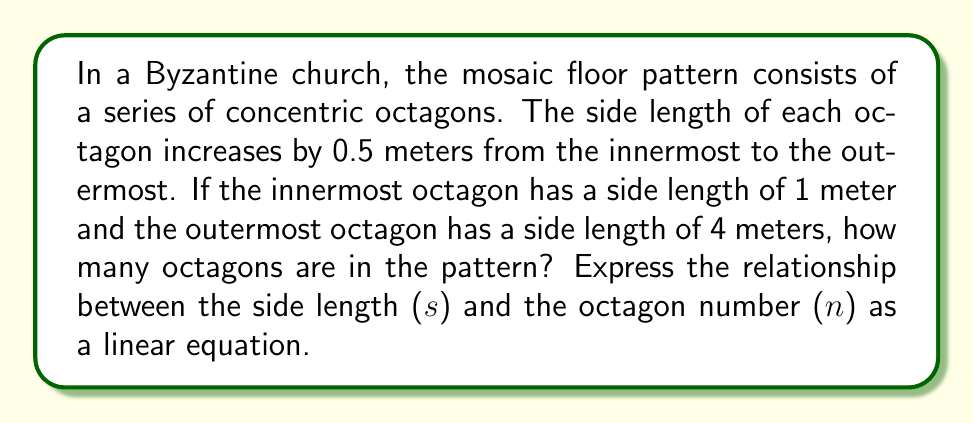Help me with this question. To solve this problem, we need to follow these steps:

1. Identify the pattern:
   The side length increases by 0.5 meters for each subsequent octagon.

2. Set up a linear equation:
   Let $s$ be the side length and $n$ be the octagon number (starting from 1).
   The linear equation can be expressed as:
   $$s = 0.5n + 0.5$$

3. Verify the equation:
   For the innermost octagon (n = 1): $s = 0.5(1) + 0.5 = 1$ meter
   For the outermost octagon: $s = 4$ meters

4. Solve for n when s = 4:
   $$4 = 0.5n + 0.5$$
   $$3.5 = 0.5n$$
   $$n = 7$$

5. Count the octagons:
   Since n starts at 1 and goes up to 7, there are 7 octagons in total.

[asy]
size(200);
for(int i=1; i<=7; ++i) {
  path p = scale(i*0.5+0.5)*polygon(8);
  draw(p);
}
[/asy]

This diagram illustrates the concentric octagon pattern, with each octagon's side length increasing by 0.5 meters.
Answer: There are 7 octagons in the pattern. The linear equation relating the side length ($s$) to the octagon number ($n$) is $s = 0.5n + 0.5$. 